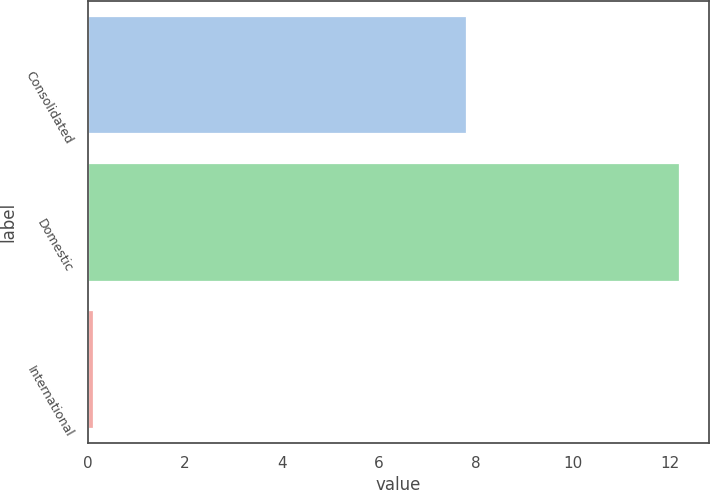Convert chart to OTSL. <chart><loc_0><loc_0><loc_500><loc_500><bar_chart><fcel>Consolidated<fcel>Domestic<fcel>International<nl><fcel>7.8<fcel>12.2<fcel>0.1<nl></chart> 